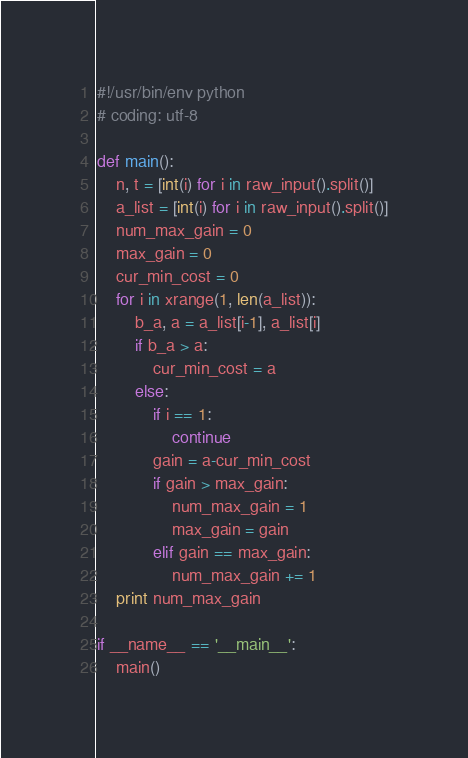Convert code to text. <code><loc_0><loc_0><loc_500><loc_500><_Python_>#!/usr/bin/env python
# coding: utf-8

def main():
    n, t = [int(i) for i in raw_input().split()]
    a_list = [int(i) for i in raw_input().split()]
    num_max_gain = 0
    max_gain = 0
    cur_min_cost = 0
    for i in xrange(1, len(a_list)):
        b_a, a = a_list[i-1], a_list[i]
        if b_a > a:
            cur_min_cost = a
        else:
            if i == 1:
                continue
            gain = a-cur_min_cost
            if gain > max_gain:
                num_max_gain = 1
                max_gain = gain
            elif gain == max_gain:
                num_max_gain += 1
    print num_max_gain

if __name__ == '__main__':
    main()
</code> 